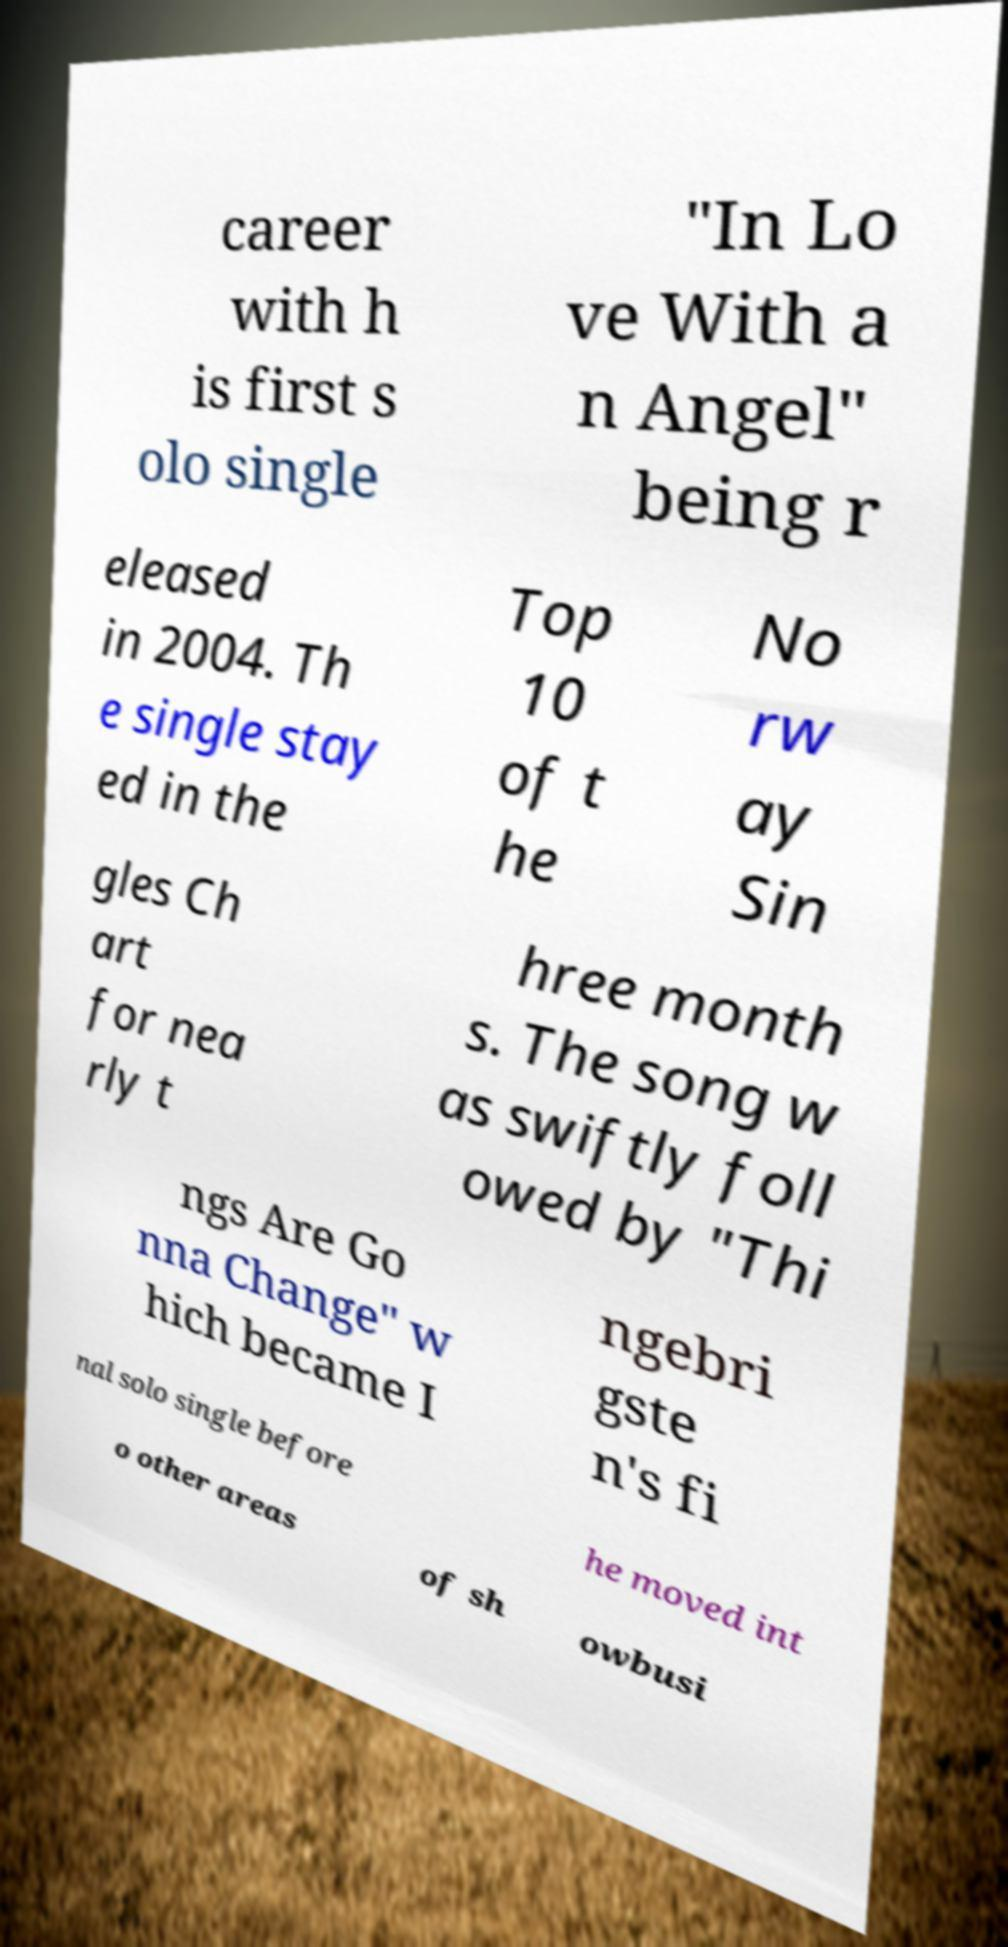For documentation purposes, I need the text within this image transcribed. Could you provide that? career with h is first s olo single "In Lo ve With a n Angel" being r eleased in 2004. Th e single stay ed in the Top 10 of t he No rw ay Sin gles Ch art for nea rly t hree month s. The song w as swiftly foll owed by "Thi ngs Are Go nna Change" w hich became I ngebri gste n's fi nal solo single before he moved int o other areas of sh owbusi 